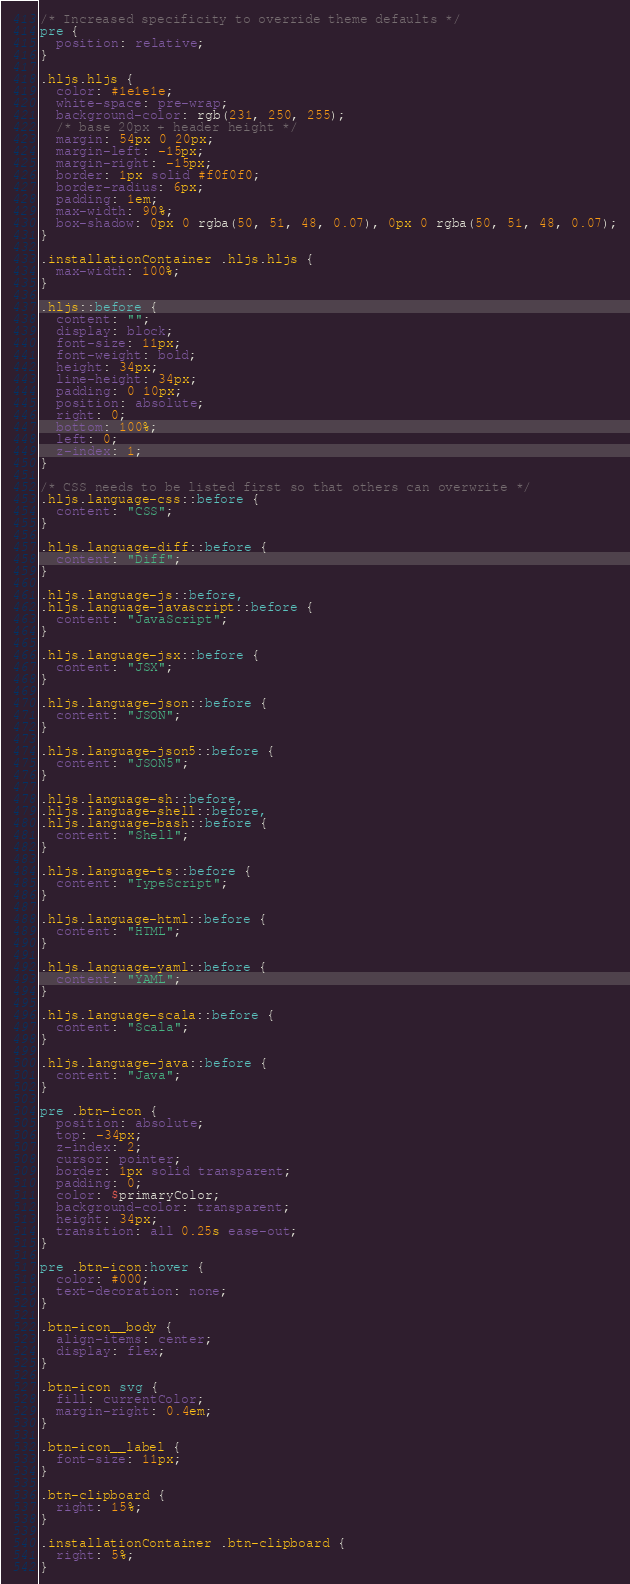<code> <loc_0><loc_0><loc_500><loc_500><_CSS_>/* Increased specificity to override theme defaults */
pre {
  position: relative;
}

.hljs.hljs {
  color: #1e1e1e;
  white-space: pre-wrap;
  background-color: rgb(231, 250, 255);
  /* base 20px + header height */
  margin: 54px 0 20px;
  margin-left: -15px;
  margin-right: -15px;
  border: 1px solid #f0f0f0;
  border-radius: 6px;
  padding: 1em;
  max-width: 90%;
  box-shadow: 0px 0 rgba(50, 51, 48, 0.07), 0px 0 rgba(50, 51, 48, 0.07);
}

.installationContainer .hljs.hljs {
  max-width: 100%;
}

.hljs::before {
  content: "";
  display: block;
  font-size: 11px;
  font-weight: bold;
  height: 34px;
  line-height: 34px;
  padding: 0 10px;
  position: absolute;
  right: 0;
  bottom: 100%;
  left: 0;
  z-index: 1;
}

/* CSS needs to be listed first so that others can overwrite */
.hljs.language-css::before {
  content: "CSS";
}

.hljs.language-diff::before {
  content: "Diff";
}

.hljs.language-js::before,
.hljs.language-javascript::before {
  content: "JavaScript";
}

.hljs.language-jsx::before {
  content: "JSX";
}

.hljs.language-json::before {
  content: "JSON";
}

.hljs.language-json5::before {
  content: "JSON5";
}

.hljs.language-sh::before,
.hljs.language-shell::before,
.hljs.language-bash::before {
  content: "Shell";
}

.hljs.language-ts::before {
  content: "TypeScript";
}

.hljs.language-html::before {
  content: "HTML";
}

.hljs.language-yaml::before {
  content: "YAML";
}

.hljs.language-scala::before {
  content: "Scala";
}

.hljs.language-java::before {
  content: "Java";
}

pre .btn-icon {
  position: absolute;
  top: -34px;
  z-index: 2;
  cursor: pointer;
  border: 1px solid transparent;
  padding: 0;
  color: $primaryColor;
  background-color: transparent;
  height: 34px;
  transition: all 0.25s ease-out;
}

pre .btn-icon:hover {
  color: #000;
  text-decoration: none;
}

.btn-icon__body {
  align-items: center;
  display: flex;
}

.btn-icon svg {
  fill: currentColor;
  margin-right: 0.4em;
}

.btn-icon__label {
  font-size: 11px;
}

.btn-clipboard {
  right: 15%;
}

.installationContainer .btn-clipboard {
  right: 5%;
}
</code> 